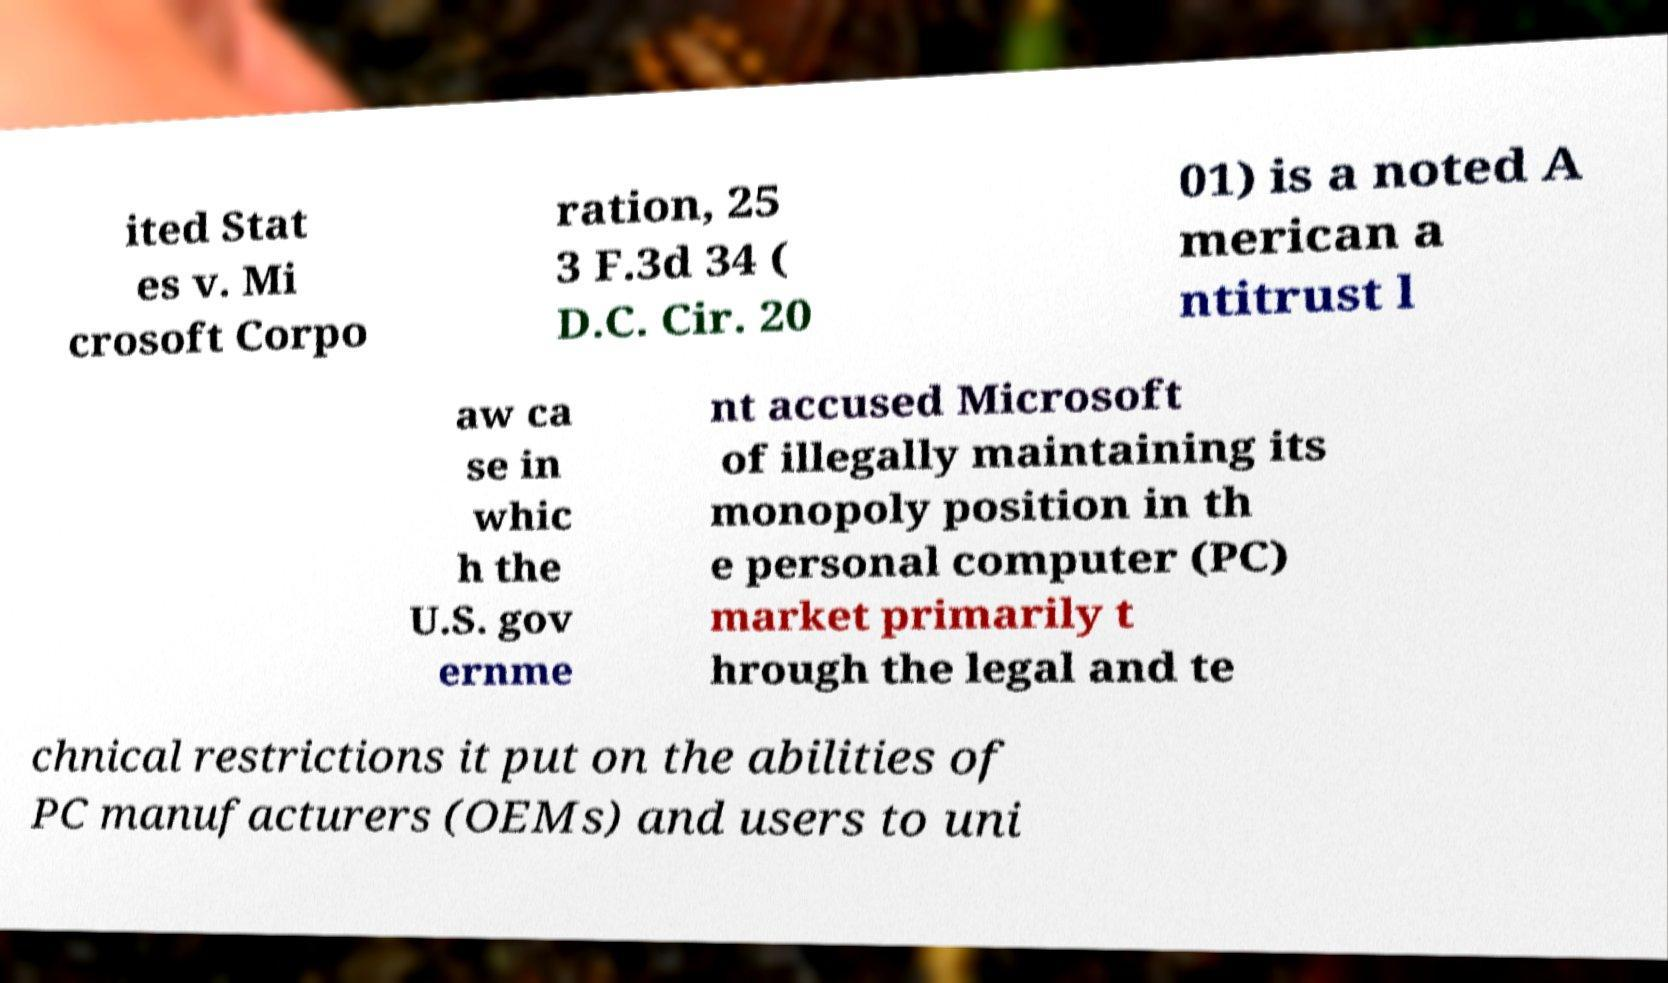There's text embedded in this image that I need extracted. Can you transcribe it verbatim? ited Stat es v. Mi crosoft Corpo ration, 25 3 F.3d 34 ( D.C. Cir. 20 01) is a noted A merican a ntitrust l aw ca se in whic h the U.S. gov ernme nt accused Microsoft of illegally maintaining its monopoly position in th e personal computer (PC) market primarily t hrough the legal and te chnical restrictions it put on the abilities of PC manufacturers (OEMs) and users to uni 